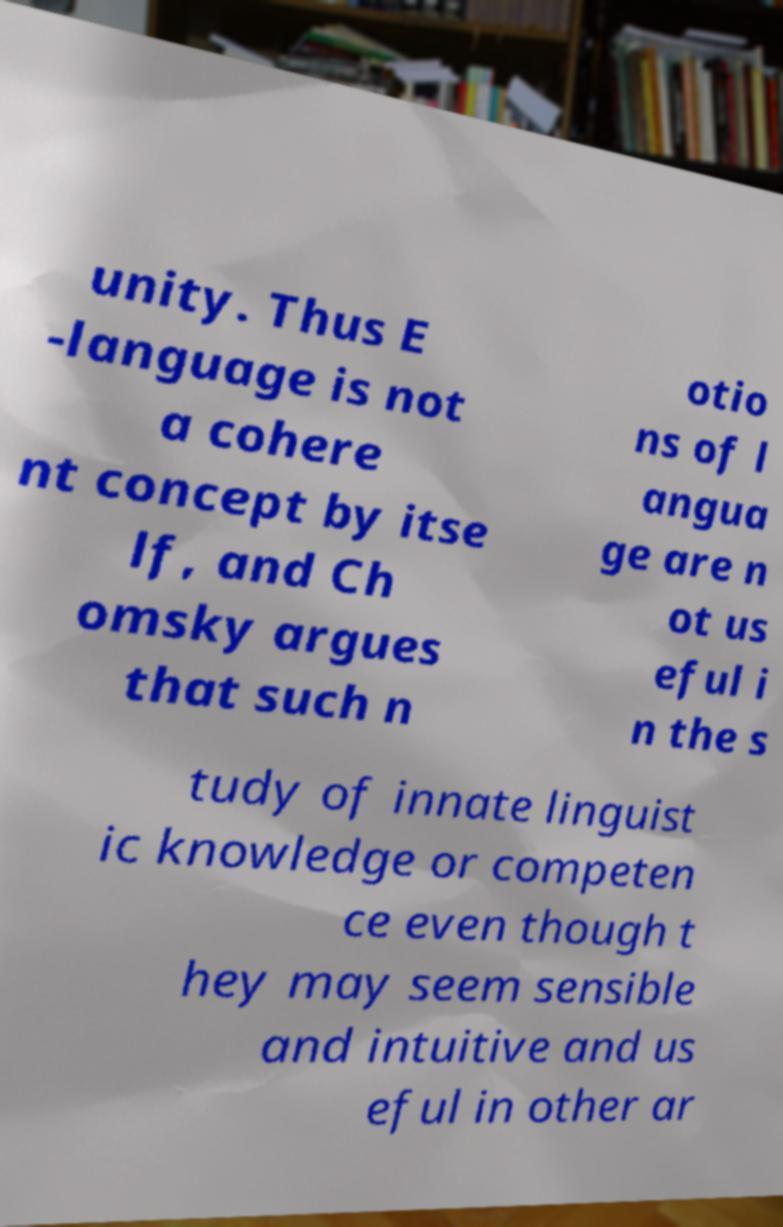Could you assist in decoding the text presented in this image and type it out clearly? unity. Thus E -language is not a cohere nt concept by itse lf, and Ch omsky argues that such n otio ns of l angua ge are n ot us eful i n the s tudy of innate linguist ic knowledge or competen ce even though t hey may seem sensible and intuitive and us eful in other ar 